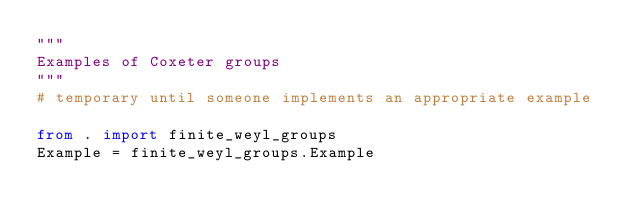Convert code to text. <code><loc_0><loc_0><loc_500><loc_500><_Python_>"""
Examples of Coxeter groups
"""
# temporary until someone implements an appropriate example

from . import finite_weyl_groups
Example = finite_weyl_groups.Example
</code> 